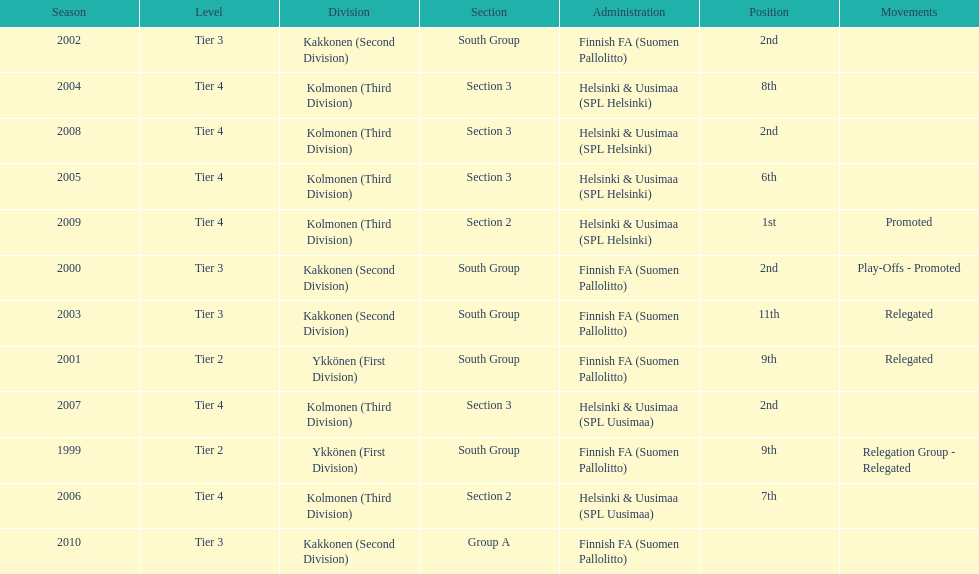How many tiers had more than one relegated movement? 1. 